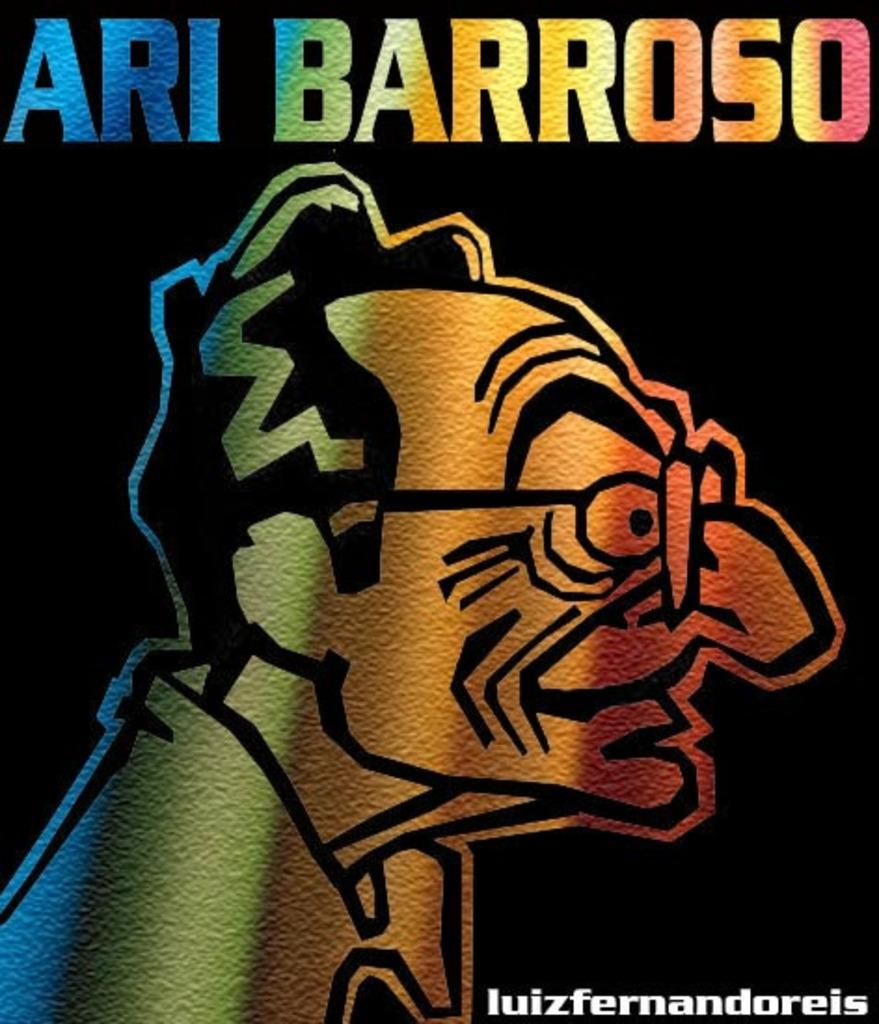What is the name of the man seen here?
Make the answer very short. Ari barroso. 